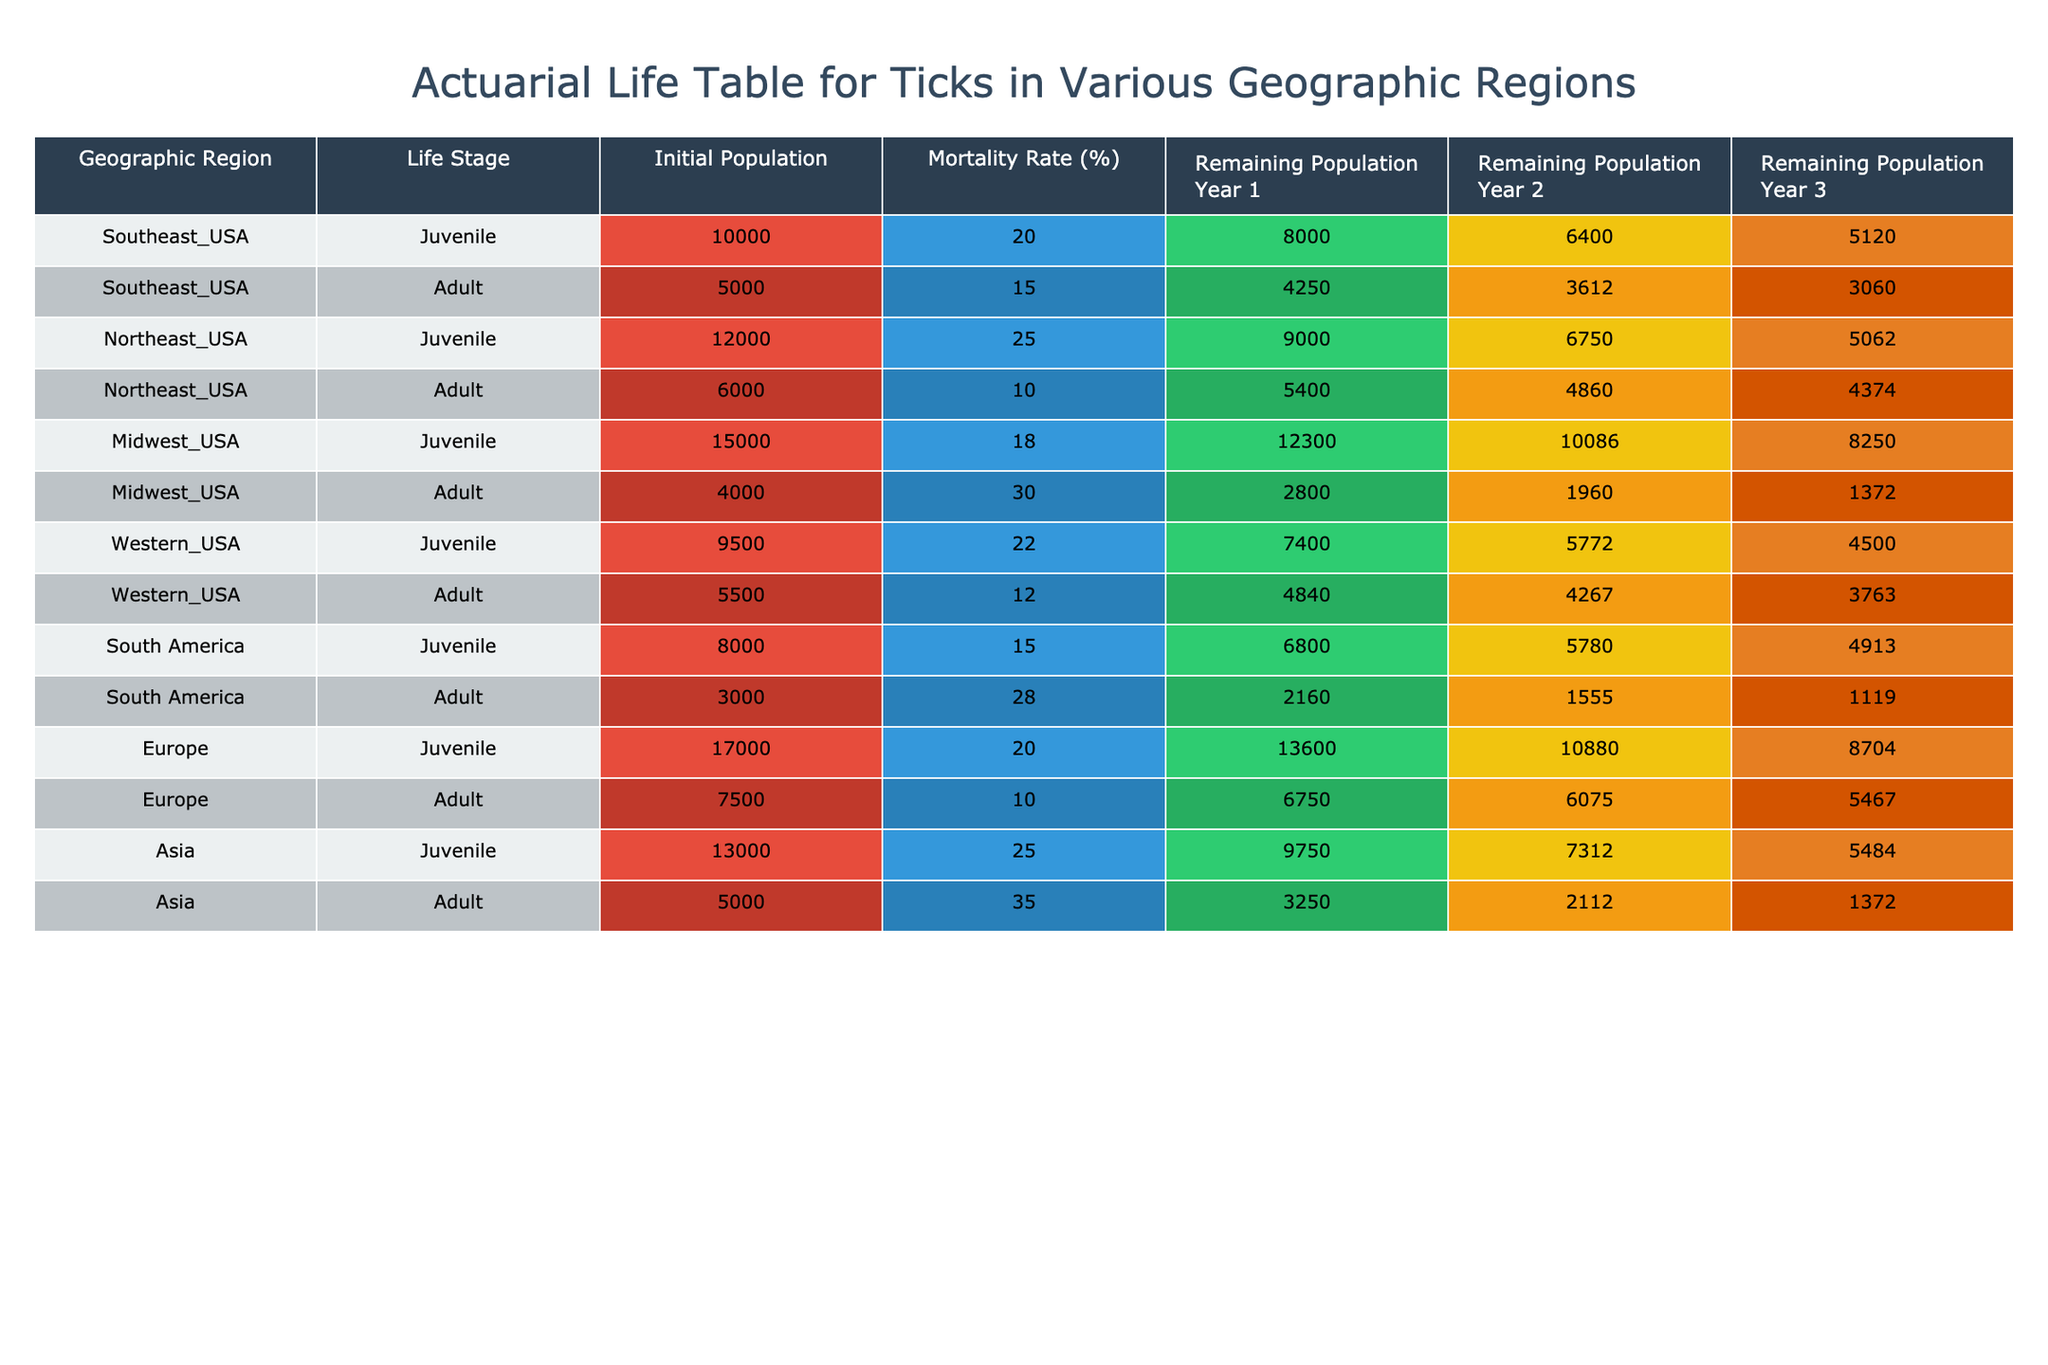What is the initial population of juvenile ticks in the Midwest USA? The table shows the Initial Population for Juvenile ticks in the Midwest USA as 15000.
Answer: 15000 What is the mortality rate percentage for adult ticks in South America? The table lists the Mortality Rate for Adult ticks in South America as 28%.
Answer: 28% Which geographic region has the highest remaining population of juvenile ticks after Year 3? Looking at the Remaining Population Year 3 for Juvenile ticks, Europe has the highest number, 8704.
Answer: Europe What is the total remaining population of adult ticks across all geographic regions after Year 1? Summing the Remaining Population Year 1 for all adult ticks: 4250 + 5400 + 2800 + 4840 + 2160 + 6750 + 3250 = 19610.
Answer: 19610 Is the mortality rate for juvenile ticks in the Northeast USA higher than that in the Southeast USA? The mortality rate for juvenile ticks in the Northeast USA is 25%, whereas in the Southeast USA it is 20%. Thus, yes, it is higher.
Answer: Yes What is the average remaining population of juvenile ticks in Year 2 across all geographic regions? The Remaining Population Year 2 for juveniles is 6400 (Southeast) + 6750 (Northeast) + 10086 (Midwest) + 5772 (Western) + 5780 (South America) + 10880 (Europe) + 7312 (Asia) = 48680. Then dividing by 7 (regions): 48680 / 7 = 6940.
Answer: 6940 How many adult ticks remain in the Western USA after Year 3? The remaining population of adult ticks in the Western USA after Year 3 is 3763, as shown in the table.
Answer: 3763 Is it true that the juvenile tick population in Asia decreases by more than 30% by Year 3? The initial population in Asia is 13000, and the remaining after Year 3 is 5484. The decrease is (13000 - 5484) / 13000 = 0.578 or 57.8%, which is greater than 30%. Thus, the statement is true.
Answer: True Which life stage of ticks has a lower average mortality rate across all regions, juveniles or adults? The average mortality rate for juveniles is (20 + 25 + 18 + 22 + 15 + 20 + 25) / 7 = 20. The average for adults is (15 + 10 + 30 + 12 + 28 + 10 + 35) / 7 = 19.4. Thus, adults have a lower average mortality rate.
Answer: Adults 